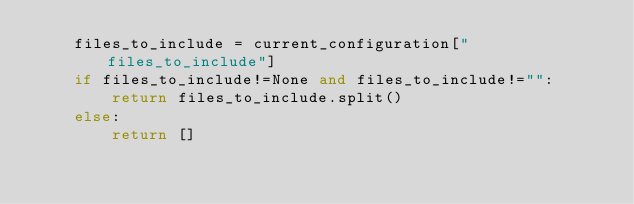Convert code to text. <code><loc_0><loc_0><loc_500><loc_500><_Python_>    files_to_include = current_configuration["files_to_include"]
    if files_to_include!=None and files_to_include!="":
        return files_to_include.split()
    else:
        return []
</code> 